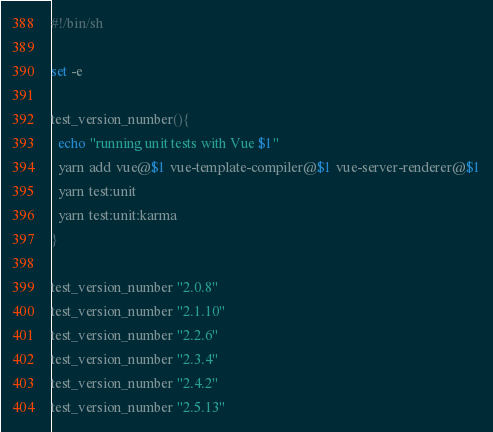<code> <loc_0><loc_0><loc_500><loc_500><_Bash_>#!/bin/sh

set -e

test_version_number(){
  echo "running unit tests with Vue $1"
  yarn add vue@$1 vue-template-compiler@$1 vue-server-renderer@$1
  yarn test:unit
  yarn test:unit:karma
}

test_version_number "2.0.8"
test_version_number "2.1.10"
test_version_number "2.2.6"
test_version_number "2.3.4"
test_version_number "2.4.2"
test_version_number "2.5.13"
</code> 